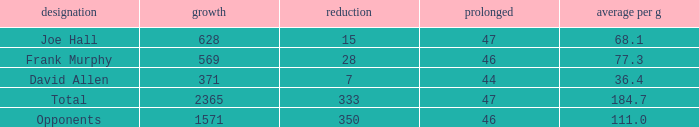Which Avg/G has a Name of david allen, and a Gain larger than 371? None. 